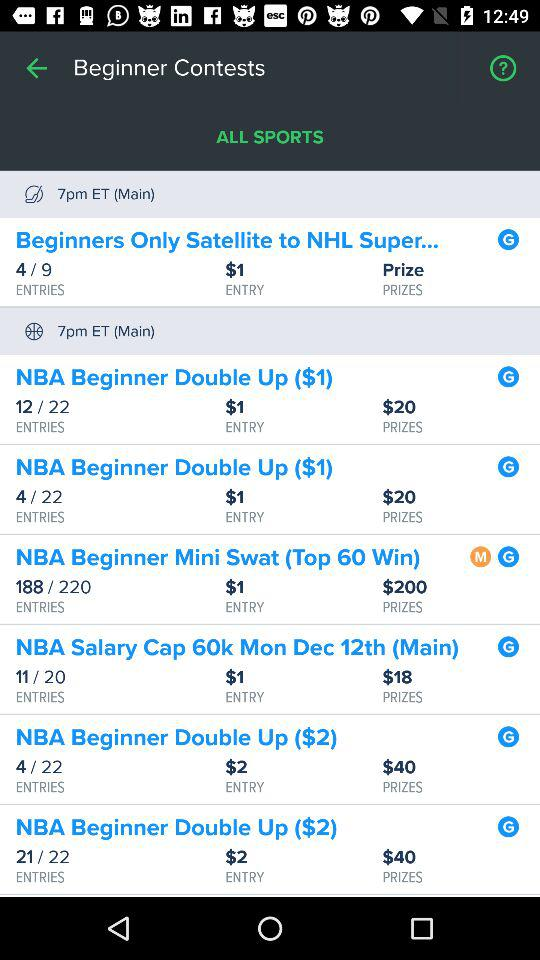How many entries have been filled out for the "NBA Beginner Mini Swat (Top 60 Win)"? The number of entries that have been filled out for the "NBA Beginner Mini Swat (Top 60 Win)" is 188. 